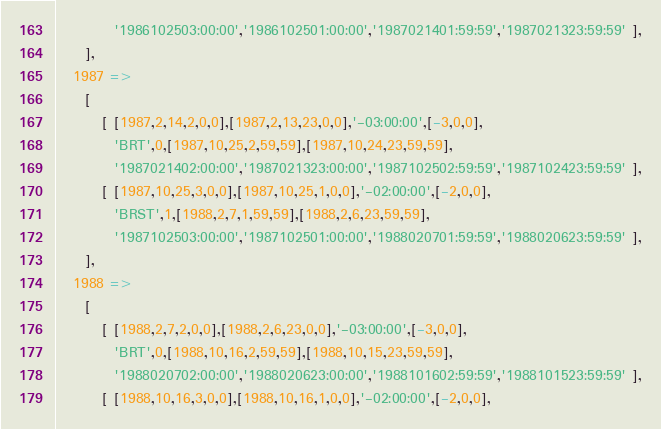Convert code to text. <code><loc_0><loc_0><loc_500><loc_500><_Perl_>          '1986102503:00:00','1986102501:00:00','1987021401:59:59','1987021323:59:59' ],
     ],
   1987 =>
     [
        [ [1987,2,14,2,0,0],[1987,2,13,23,0,0],'-03:00:00',[-3,0,0],
          'BRT',0,[1987,10,25,2,59,59],[1987,10,24,23,59,59],
          '1987021402:00:00','1987021323:00:00','1987102502:59:59','1987102423:59:59' ],
        [ [1987,10,25,3,0,0],[1987,10,25,1,0,0],'-02:00:00',[-2,0,0],
          'BRST',1,[1988,2,7,1,59,59],[1988,2,6,23,59,59],
          '1987102503:00:00','1987102501:00:00','1988020701:59:59','1988020623:59:59' ],
     ],
   1988 =>
     [
        [ [1988,2,7,2,0,0],[1988,2,6,23,0,0],'-03:00:00',[-3,0,0],
          'BRT',0,[1988,10,16,2,59,59],[1988,10,15,23,59,59],
          '1988020702:00:00','1988020623:00:00','1988101602:59:59','1988101523:59:59' ],
        [ [1988,10,16,3,0,0],[1988,10,16,1,0,0],'-02:00:00',[-2,0,0],</code> 